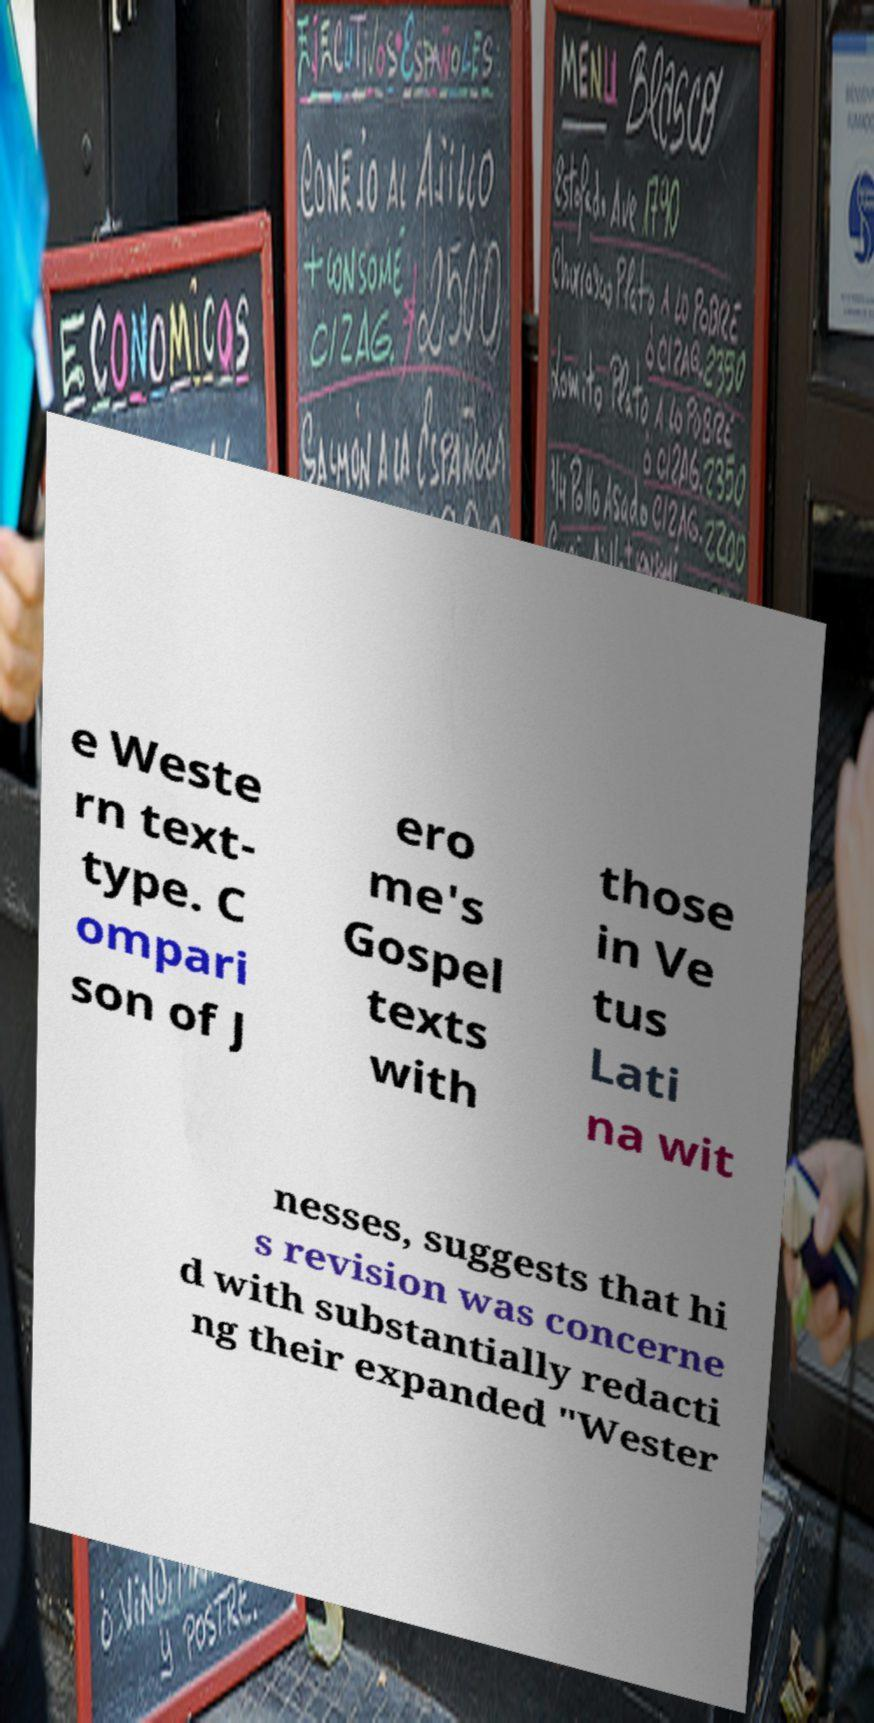Could you assist in decoding the text presented in this image and type it out clearly? e Weste rn text- type. C ompari son of J ero me's Gospel texts with those in Ve tus Lati na wit nesses, suggests that hi s revision was concerne d with substantially redacti ng their expanded "Wester 